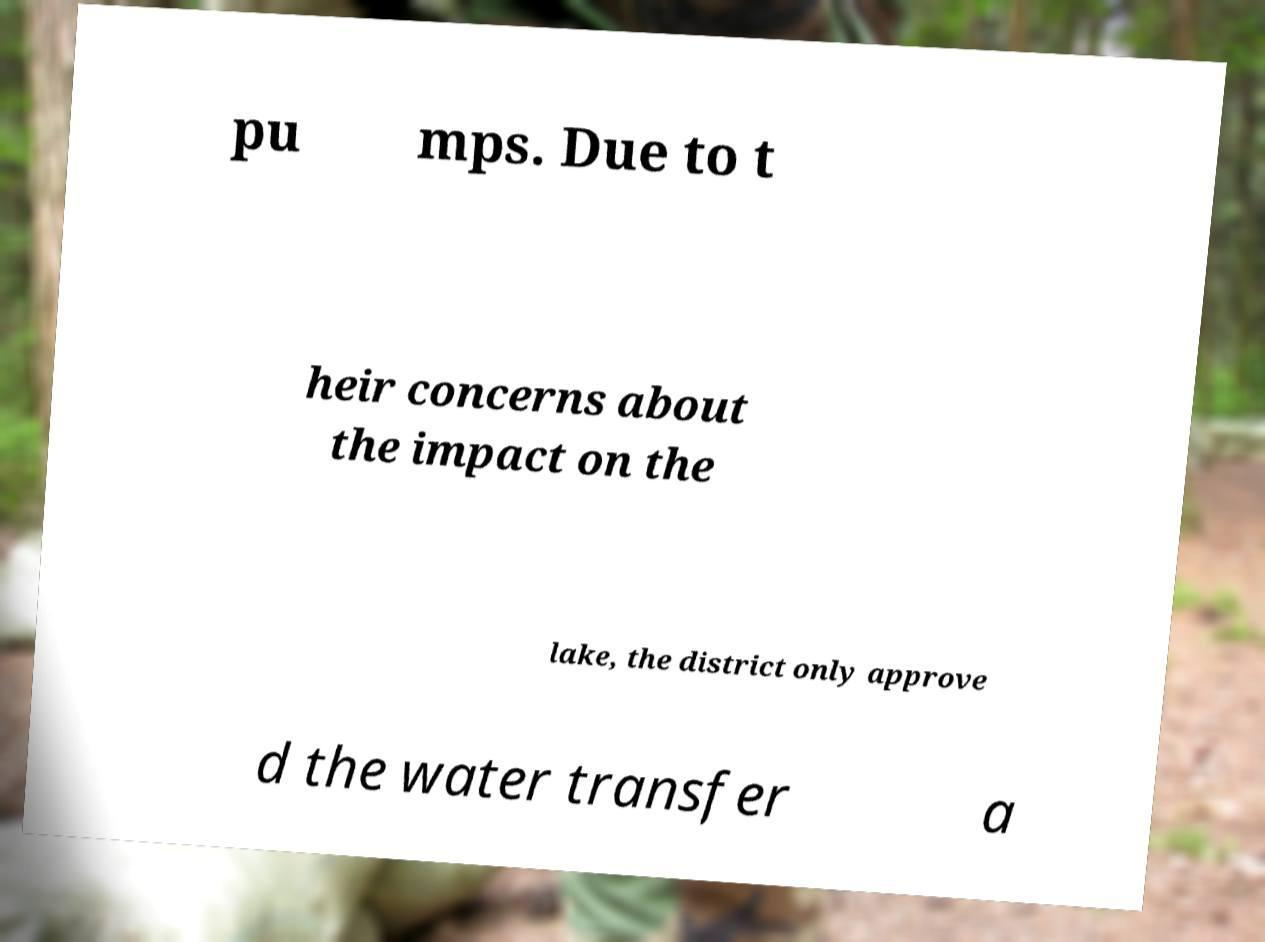I need the written content from this picture converted into text. Can you do that? pu mps. Due to t heir concerns about the impact on the lake, the district only approve d the water transfer a 